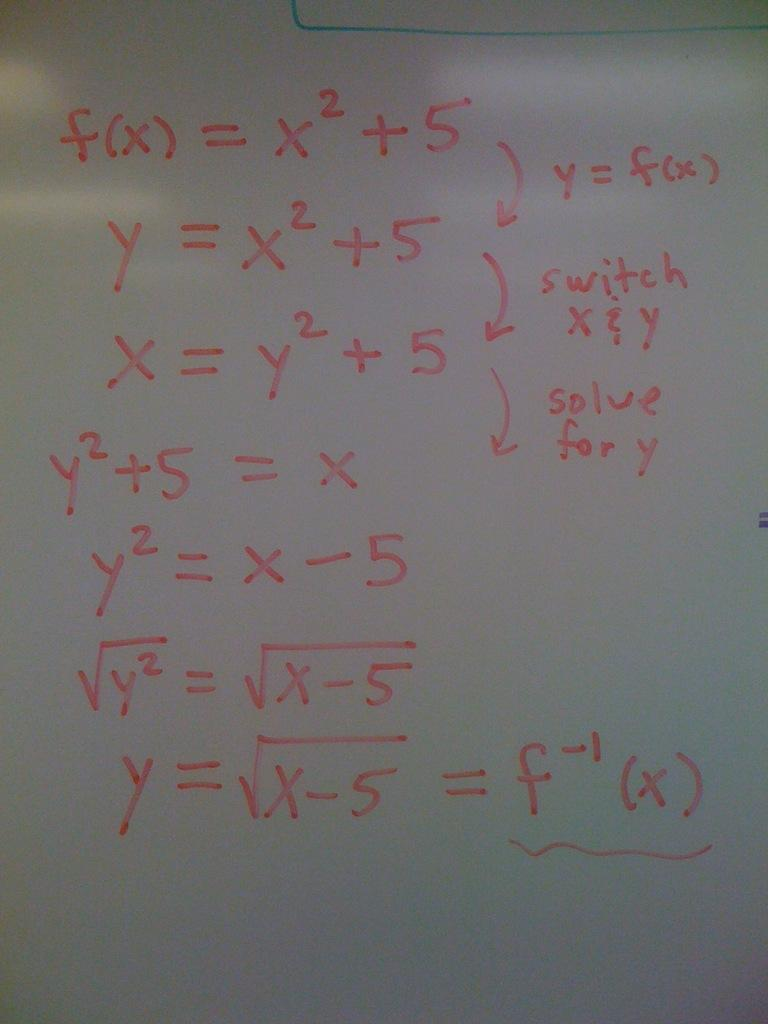<image>
Render a clear and concise summary of the photo. Math equations on a whiteboard include f(x) equals x squared plus five. 